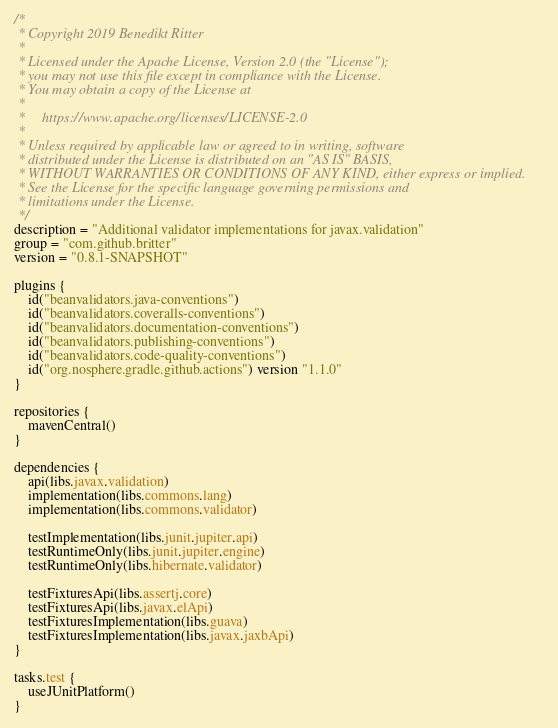Convert code to text. <code><loc_0><loc_0><loc_500><loc_500><_Kotlin_>/*
 * Copyright 2019 Benedikt Ritter
 *
 * Licensed under the Apache License, Version 2.0 (the "License");
 * you may not use this file except in compliance with the License.
 * You may obtain a copy of the License at
 *
 *     https://www.apache.org/licenses/LICENSE-2.0
 *
 * Unless required by applicable law or agreed to in writing, software
 * distributed under the License is distributed on an "AS IS" BASIS,
 * WITHOUT WARRANTIES OR CONDITIONS OF ANY KIND, either express or implied.
 * See the License for the specific language governing permissions and
 * limitations under the License.
 */
description = "Additional validator implementations for javax.validation"
group = "com.github.britter"
version = "0.8.1-SNAPSHOT"

plugins {
    id("beanvalidators.java-conventions")
    id("beanvalidators.coveralls-conventions")
    id("beanvalidators.documentation-conventions")
    id("beanvalidators.publishing-conventions")
    id("beanvalidators.code-quality-conventions")
    id("org.nosphere.gradle.github.actions") version "1.1.0"
}

repositories {
    mavenCentral()
}

dependencies {
    api(libs.javax.validation)
    implementation(libs.commons.lang)
    implementation(libs.commons.validator)

    testImplementation(libs.junit.jupiter.api)
    testRuntimeOnly(libs.junit.jupiter.engine)
    testRuntimeOnly(libs.hibernate.validator)

    testFixturesApi(libs.assertj.core)
    testFixturesApi(libs.javax.elApi)
    testFixturesImplementation(libs.guava)
    testFixturesImplementation(libs.javax.jaxbApi)
}

tasks.test {
    useJUnitPlatform()
}
</code> 